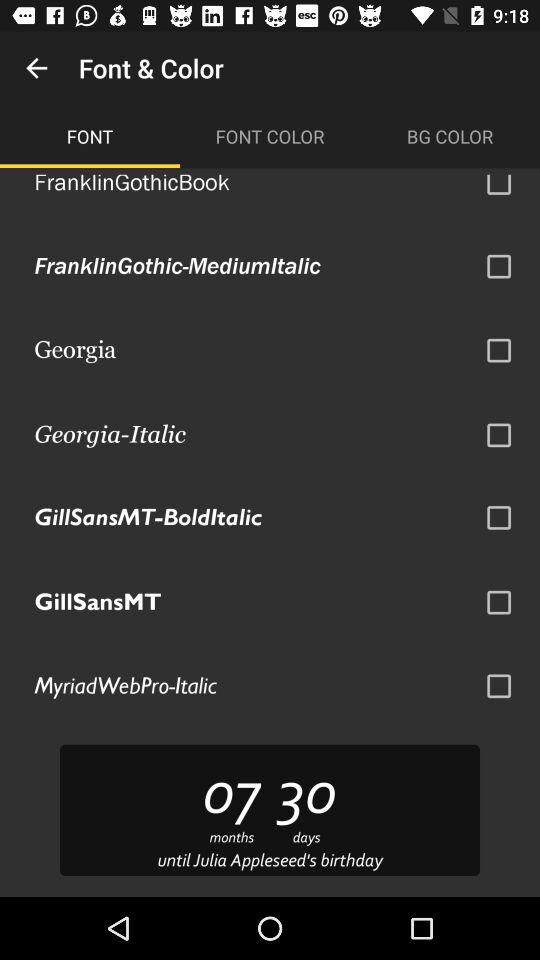Which tab is currently selected? The currently selected tab is "FONT". 